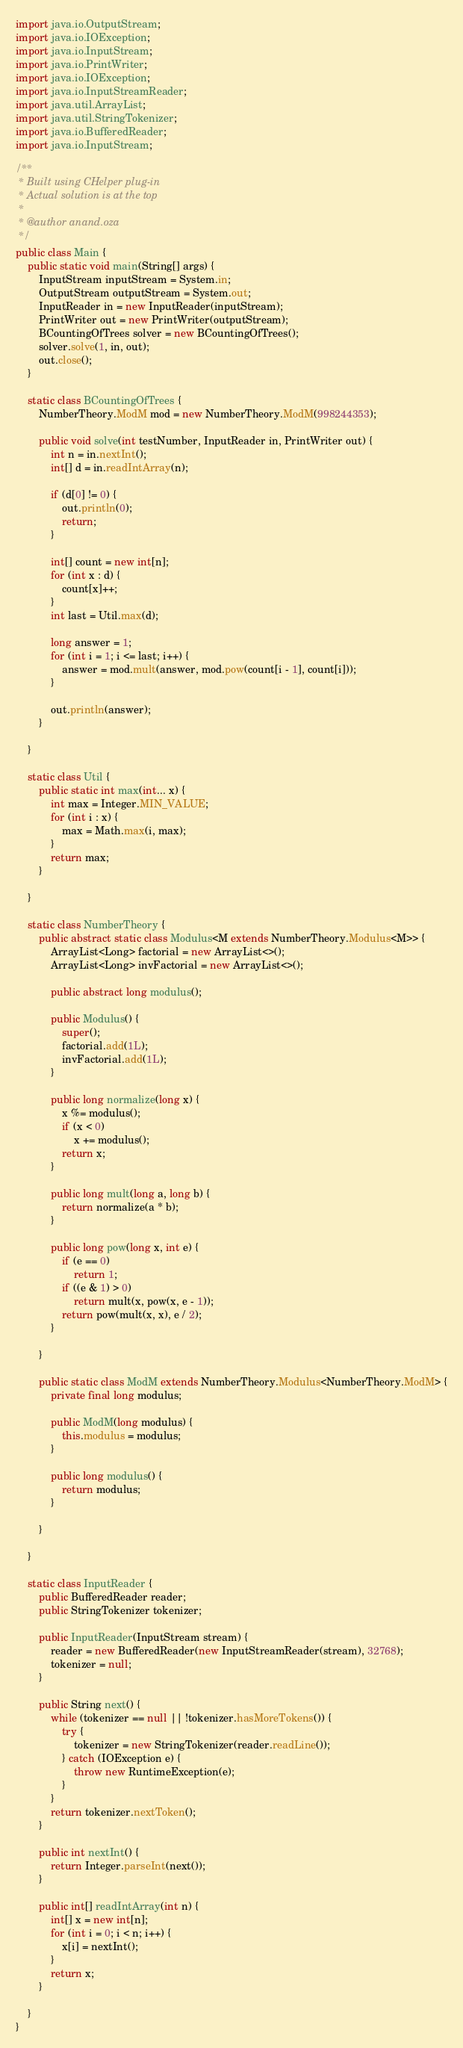Convert code to text. <code><loc_0><loc_0><loc_500><loc_500><_Java_>import java.io.OutputStream;
import java.io.IOException;
import java.io.InputStream;
import java.io.PrintWriter;
import java.io.IOException;
import java.io.InputStreamReader;
import java.util.ArrayList;
import java.util.StringTokenizer;
import java.io.BufferedReader;
import java.io.InputStream;

/**
 * Built using CHelper plug-in
 * Actual solution is at the top
 *
 * @author anand.oza
 */
public class Main {
    public static void main(String[] args) {
        InputStream inputStream = System.in;
        OutputStream outputStream = System.out;
        InputReader in = new InputReader(inputStream);
        PrintWriter out = new PrintWriter(outputStream);
        BCountingOfTrees solver = new BCountingOfTrees();
        solver.solve(1, in, out);
        out.close();
    }

    static class BCountingOfTrees {
        NumberTheory.ModM mod = new NumberTheory.ModM(998244353);

        public void solve(int testNumber, InputReader in, PrintWriter out) {
            int n = in.nextInt();
            int[] d = in.readIntArray(n);

            if (d[0] != 0) {
                out.println(0);
                return;
            }

            int[] count = new int[n];
            for (int x : d) {
                count[x]++;
            }
            int last = Util.max(d);

            long answer = 1;
            for (int i = 1; i <= last; i++) {
                answer = mod.mult(answer, mod.pow(count[i - 1], count[i]));
            }

            out.println(answer);
        }

    }

    static class Util {
        public static int max(int... x) {
            int max = Integer.MIN_VALUE;
            for (int i : x) {
                max = Math.max(i, max);
            }
            return max;
        }

    }

    static class NumberTheory {
        public abstract static class Modulus<M extends NumberTheory.Modulus<M>> {
            ArrayList<Long> factorial = new ArrayList<>();
            ArrayList<Long> invFactorial = new ArrayList<>();

            public abstract long modulus();

            public Modulus() {
                super();
                factorial.add(1L);
                invFactorial.add(1L);
            }

            public long normalize(long x) {
                x %= modulus();
                if (x < 0)
                    x += modulus();
                return x;
            }

            public long mult(long a, long b) {
                return normalize(a * b);
            }

            public long pow(long x, int e) {
                if (e == 0)
                    return 1;
                if ((e & 1) > 0)
                    return mult(x, pow(x, e - 1));
                return pow(mult(x, x), e / 2);
            }

        }

        public static class ModM extends NumberTheory.Modulus<NumberTheory.ModM> {
            private final long modulus;

            public ModM(long modulus) {
                this.modulus = modulus;
            }

            public long modulus() {
                return modulus;
            }

        }

    }

    static class InputReader {
        public BufferedReader reader;
        public StringTokenizer tokenizer;

        public InputReader(InputStream stream) {
            reader = new BufferedReader(new InputStreamReader(stream), 32768);
            tokenizer = null;
        }

        public String next() {
            while (tokenizer == null || !tokenizer.hasMoreTokens()) {
                try {
                    tokenizer = new StringTokenizer(reader.readLine());
                } catch (IOException e) {
                    throw new RuntimeException(e);
                }
            }
            return tokenizer.nextToken();
        }

        public int nextInt() {
            return Integer.parseInt(next());
        }

        public int[] readIntArray(int n) {
            int[] x = new int[n];
            for (int i = 0; i < n; i++) {
                x[i] = nextInt();
            }
            return x;
        }

    }
}

</code> 